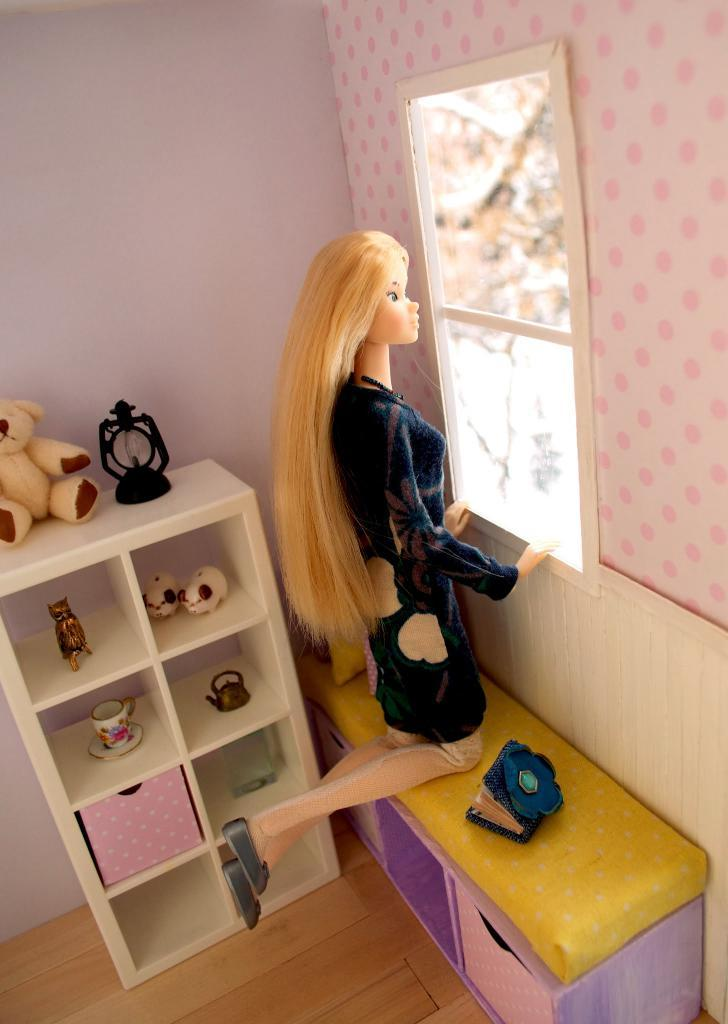What type of space is shown in the image? The image is an inside view of a room. What furniture can be seen in the room? There is a table, a bench, and a cup in the room. What items are present in the room? There are toys, a book, a watch, and a cup in the room. What architectural features can be seen in the room? There is a wall, a window, and a floor in the room. Can you tell me how many dimes are scattered on the floor in the image? There are no dimes present in the image; it only shows a room with a table, bench, toys, a book, a watch, a cup, a wall, a window, and a floor. Is there a cave visible in the image? No, there is no cave present in the image; it is an inside view of a room. 